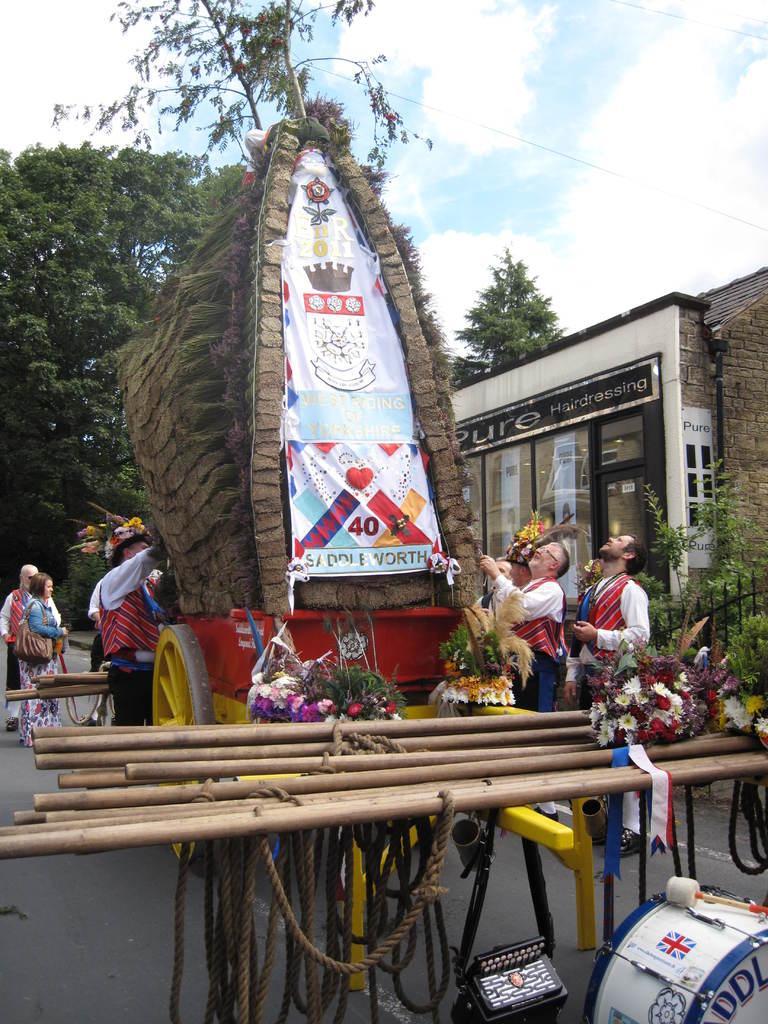In one or two sentences, can you explain what this image depicts? In this image we can see a decorated cart and men standing beside it. On the cart we can see bamboo sticks, bouquets, ropes and an advertisement. In the background there are buildings, grills, trees, road, person standing on the road and sky with clouds. 